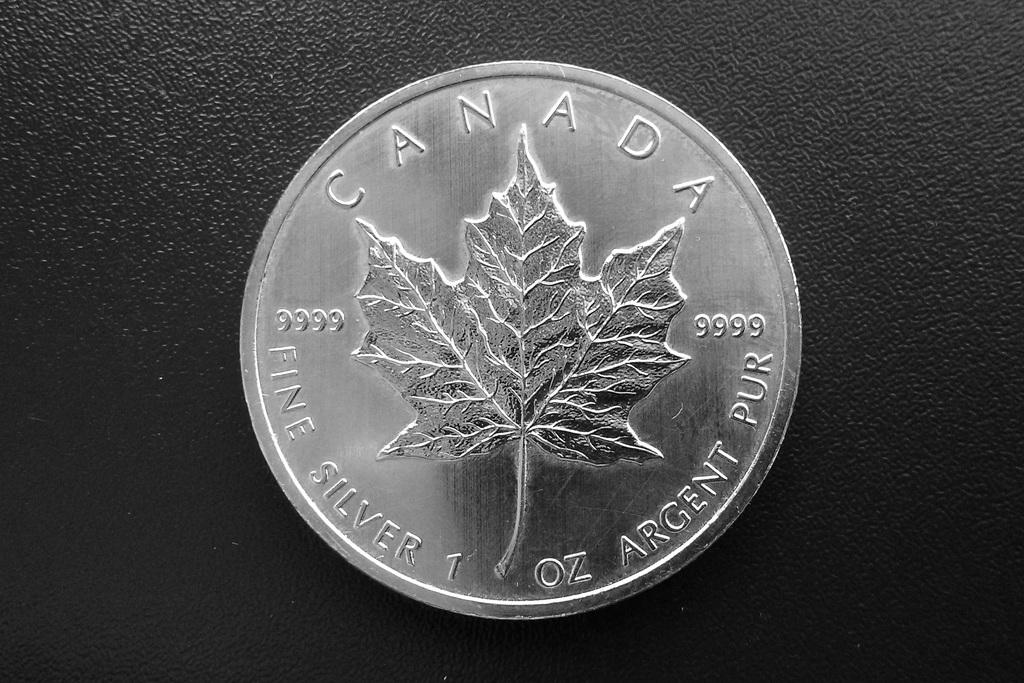<image>
Offer a succinct explanation of the picture presented. A silver Canada coin with a leaf symbol on face. 